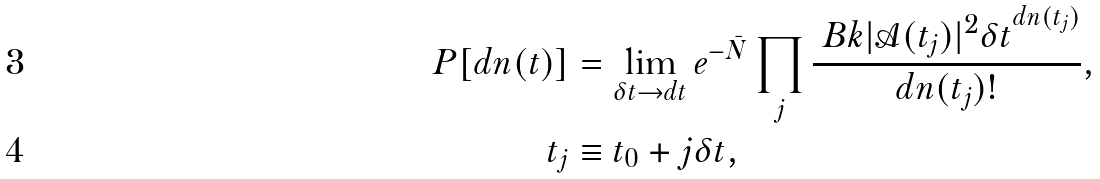<formula> <loc_0><loc_0><loc_500><loc_500>P [ d n ( t ) ] & = \lim _ { \delta t \to d t } e ^ { - \bar { N } } \prod _ { j } \frac { \ B k { | \mathcal { A } ( t _ { j } ) | ^ { 2 } \delta t } ^ { d n ( t _ { j } ) } } { d n ( t _ { j } ) ! } , \\ t _ { j } & \equiv t _ { 0 } + j \delta t ,</formula> 